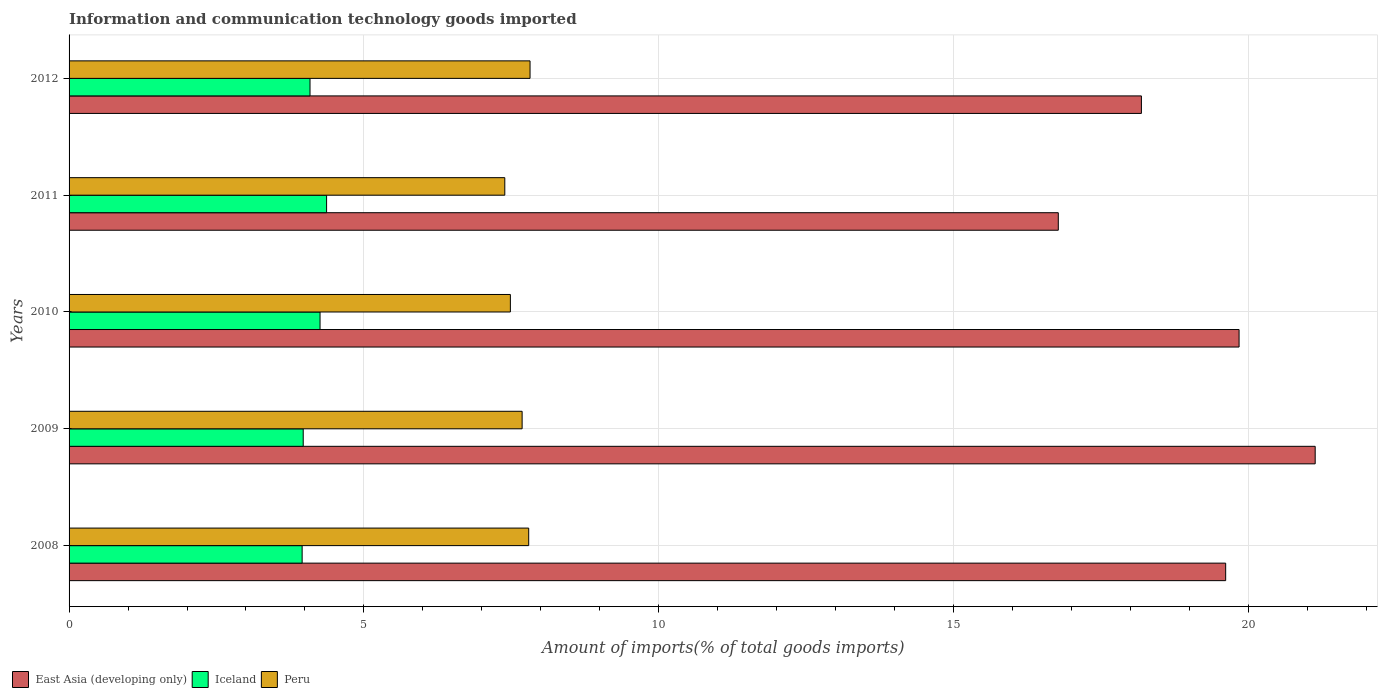How many different coloured bars are there?
Offer a very short reply. 3. How many bars are there on the 4th tick from the top?
Make the answer very short. 3. How many bars are there on the 4th tick from the bottom?
Keep it short and to the point. 3. What is the label of the 1st group of bars from the top?
Your answer should be compact. 2012. In how many cases, is the number of bars for a given year not equal to the number of legend labels?
Your response must be concise. 0. What is the amount of goods imported in Iceland in 2008?
Provide a short and direct response. 3.95. Across all years, what is the maximum amount of goods imported in Peru?
Your answer should be very brief. 7.82. Across all years, what is the minimum amount of goods imported in Peru?
Your answer should be very brief. 7.39. In which year was the amount of goods imported in Iceland maximum?
Provide a succinct answer. 2011. What is the total amount of goods imported in Peru in the graph?
Provide a succinct answer. 38.17. What is the difference between the amount of goods imported in Peru in 2008 and that in 2011?
Make the answer very short. 0.41. What is the difference between the amount of goods imported in Peru in 2011 and the amount of goods imported in Iceland in 2008?
Make the answer very short. 3.44. What is the average amount of goods imported in East Asia (developing only) per year?
Make the answer very short. 19.11. In the year 2008, what is the difference between the amount of goods imported in East Asia (developing only) and amount of goods imported in Peru?
Your response must be concise. 11.82. What is the ratio of the amount of goods imported in East Asia (developing only) in 2009 to that in 2010?
Provide a short and direct response. 1.07. Is the amount of goods imported in Peru in 2008 less than that in 2009?
Provide a succinct answer. No. Is the difference between the amount of goods imported in East Asia (developing only) in 2008 and 2009 greater than the difference between the amount of goods imported in Peru in 2008 and 2009?
Give a very brief answer. No. What is the difference between the highest and the second highest amount of goods imported in Peru?
Your answer should be compact. 0.02. What is the difference between the highest and the lowest amount of goods imported in Iceland?
Your answer should be very brief. 0.41. Is the sum of the amount of goods imported in Iceland in 2009 and 2011 greater than the maximum amount of goods imported in Peru across all years?
Make the answer very short. Yes. What does the 3rd bar from the top in 2009 represents?
Provide a short and direct response. East Asia (developing only). What does the 1st bar from the bottom in 2008 represents?
Offer a very short reply. East Asia (developing only). How many bars are there?
Offer a very short reply. 15. Are all the bars in the graph horizontal?
Give a very brief answer. Yes. What is the difference between two consecutive major ticks on the X-axis?
Make the answer very short. 5. Are the values on the major ticks of X-axis written in scientific E-notation?
Your response must be concise. No. Does the graph contain grids?
Your answer should be compact. Yes. Where does the legend appear in the graph?
Make the answer very short. Bottom left. How many legend labels are there?
Make the answer very short. 3. What is the title of the graph?
Make the answer very short. Information and communication technology goods imported. What is the label or title of the X-axis?
Your response must be concise. Amount of imports(% of total goods imports). What is the Amount of imports(% of total goods imports) in East Asia (developing only) in 2008?
Offer a very short reply. 19.62. What is the Amount of imports(% of total goods imports) of Iceland in 2008?
Offer a very short reply. 3.95. What is the Amount of imports(% of total goods imports) in Peru in 2008?
Keep it short and to the point. 7.8. What is the Amount of imports(% of total goods imports) in East Asia (developing only) in 2009?
Provide a succinct answer. 21.13. What is the Amount of imports(% of total goods imports) in Iceland in 2009?
Make the answer very short. 3.97. What is the Amount of imports(% of total goods imports) of Peru in 2009?
Provide a short and direct response. 7.68. What is the Amount of imports(% of total goods imports) in East Asia (developing only) in 2010?
Give a very brief answer. 19.84. What is the Amount of imports(% of total goods imports) of Iceland in 2010?
Ensure brevity in your answer.  4.26. What is the Amount of imports(% of total goods imports) in Peru in 2010?
Offer a terse response. 7.48. What is the Amount of imports(% of total goods imports) of East Asia (developing only) in 2011?
Make the answer very short. 16.78. What is the Amount of imports(% of total goods imports) in Iceland in 2011?
Offer a very short reply. 4.37. What is the Amount of imports(% of total goods imports) in Peru in 2011?
Provide a short and direct response. 7.39. What is the Amount of imports(% of total goods imports) in East Asia (developing only) in 2012?
Give a very brief answer. 18.19. What is the Amount of imports(% of total goods imports) in Iceland in 2012?
Your response must be concise. 4.09. What is the Amount of imports(% of total goods imports) of Peru in 2012?
Your answer should be compact. 7.82. Across all years, what is the maximum Amount of imports(% of total goods imports) in East Asia (developing only)?
Offer a very short reply. 21.13. Across all years, what is the maximum Amount of imports(% of total goods imports) in Iceland?
Your answer should be compact. 4.37. Across all years, what is the maximum Amount of imports(% of total goods imports) of Peru?
Your answer should be compact. 7.82. Across all years, what is the minimum Amount of imports(% of total goods imports) of East Asia (developing only)?
Your answer should be compact. 16.78. Across all years, what is the minimum Amount of imports(% of total goods imports) in Iceland?
Your response must be concise. 3.95. Across all years, what is the minimum Amount of imports(% of total goods imports) in Peru?
Offer a terse response. 7.39. What is the total Amount of imports(% of total goods imports) in East Asia (developing only) in the graph?
Offer a very short reply. 95.56. What is the total Amount of imports(% of total goods imports) in Iceland in the graph?
Provide a succinct answer. 20.64. What is the total Amount of imports(% of total goods imports) of Peru in the graph?
Make the answer very short. 38.17. What is the difference between the Amount of imports(% of total goods imports) of East Asia (developing only) in 2008 and that in 2009?
Keep it short and to the point. -1.52. What is the difference between the Amount of imports(% of total goods imports) of Iceland in 2008 and that in 2009?
Your answer should be very brief. -0.02. What is the difference between the Amount of imports(% of total goods imports) of Peru in 2008 and that in 2009?
Give a very brief answer. 0.11. What is the difference between the Amount of imports(% of total goods imports) in East Asia (developing only) in 2008 and that in 2010?
Your answer should be compact. -0.23. What is the difference between the Amount of imports(% of total goods imports) of Iceland in 2008 and that in 2010?
Offer a terse response. -0.3. What is the difference between the Amount of imports(% of total goods imports) of Peru in 2008 and that in 2010?
Offer a very short reply. 0.31. What is the difference between the Amount of imports(% of total goods imports) of East Asia (developing only) in 2008 and that in 2011?
Make the answer very short. 2.84. What is the difference between the Amount of imports(% of total goods imports) in Iceland in 2008 and that in 2011?
Your response must be concise. -0.41. What is the difference between the Amount of imports(% of total goods imports) of Peru in 2008 and that in 2011?
Keep it short and to the point. 0.41. What is the difference between the Amount of imports(% of total goods imports) of East Asia (developing only) in 2008 and that in 2012?
Your answer should be very brief. 1.43. What is the difference between the Amount of imports(% of total goods imports) of Iceland in 2008 and that in 2012?
Your answer should be very brief. -0.13. What is the difference between the Amount of imports(% of total goods imports) of Peru in 2008 and that in 2012?
Ensure brevity in your answer.  -0.02. What is the difference between the Amount of imports(% of total goods imports) in East Asia (developing only) in 2009 and that in 2010?
Keep it short and to the point. 1.29. What is the difference between the Amount of imports(% of total goods imports) in Iceland in 2009 and that in 2010?
Offer a very short reply. -0.29. What is the difference between the Amount of imports(% of total goods imports) in Peru in 2009 and that in 2010?
Offer a very short reply. 0.2. What is the difference between the Amount of imports(% of total goods imports) in East Asia (developing only) in 2009 and that in 2011?
Your answer should be compact. 4.36. What is the difference between the Amount of imports(% of total goods imports) of Iceland in 2009 and that in 2011?
Offer a terse response. -0.4. What is the difference between the Amount of imports(% of total goods imports) of Peru in 2009 and that in 2011?
Keep it short and to the point. 0.29. What is the difference between the Amount of imports(% of total goods imports) in East Asia (developing only) in 2009 and that in 2012?
Your response must be concise. 2.95. What is the difference between the Amount of imports(% of total goods imports) in Iceland in 2009 and that in 2012?
Offer a terse response. -0.12. What is the difference between the Amount of imports(% of total goods imports) in Peru in 2009 and that in 2012?
Provide a short and direct response. -0.13. What is the difference between the Amount of imports(% of total goods imports) of East Asia (developing only) in 2010 and that in 2011?
Provide a succinct answer. 3.07. What is the difference between the Amount of imports(% of total goods imports) of Iceland in 2010 and that in 2011?
Provide a succinct answer. -0.11. What is the difference between the Amount of imports(% of total goods imports) of Peru in 2010 and that in 2011?
Your response must be concise. 0.09. What is the difference between the Amount of imports(% of total goods imports) in East Asia (developing only) in 2010 and that in 2012?
Keep it short and to the point. 1.66. What is the difference between the Amount of imports(% of total goods imports) of Iceland in 2010 and that in 2012?
Your answer should be very brief. 0.17. What is the difference between the Amount of imports(% of total goods imports) of Peru in 2010 and that in 2012?
Ensure brevity in your answer.  -0.33. What is the difference between the Amount of imports(% of total goods imports) of East Asia (developing only) in 2011 and that in 2012?
Ensure brevity in your answer.  -1.41. What is the difference between the Amount of imports(% of total goods imports) in Iceland in 2011 and that in 2012?
Provide a succinct answer. 0.28. What is the difference between the Amount of imports(% of total goods imports) in Peru in 2011 and that in 2012?
Offer a terse response. -0.43. What is the difference between the Amount of imports(% of total goods imports) of East Asia (developing only) in 2008 and the Amount of imports(% of total goods imports) of Iceland in 2009?
Make the answer very short. 15.64. What is the difference between the Amount of imports(% of total goods imports) of East Asia (developing only) in 2008 and the Amount of imports(% of total goods imports) of Peru in 2009?
Provide a short and direct response. 11.93. What is the difference between the Amount of imports(% of total goods imports) in Iceland in 2008 and the Amount of imports(% of total goods imports) in Peru in 2009?
Provide a succinct answer. -3.73. What is the difference between the Amount of imports(% of total goods imports) in East Asia (developing only) in 2008 and the Amount of imports(% of total goods imports) in Iceland in 2010?
Give a very brief answer. 15.36. What is the difference between the Amount of imports(% of total goods imports) of East Asia (developing only) in 2008 and the Amount of imports(% of total goods imports) of Peru in 2010?
Offer a terse response. 12.13. What is the difference between the Amount of imports(% of total goods imports) of Iceland in 2008 and the Amount of imports(% of total goods imports) of Peru in 2010?
Your response must be concise. -3.53. What is the difference between the Amount of imports(% of total goods imports) of East Asia (developing only) in 2008 and the Amount of imports(% of total goods imports) of Iceland in 2011?
Make the answer very short. 15.25. What is the difference between the Amount of imports(% of total goods imports) of East Asia (developing only) in 2008 and the Amount of imports(% of total goods imports) of Peru in 2011?
Offer a terse response. 12.23. What is the difference between the Amount of imports(% of total goods imports) in Iceland in 2008 and the Amount of imports(% of total goods imports) in Peru in 2011?
Provide a succinct answer. -3.44. What is the difference between the Amount of imports(% of total goods imports) of East Asia (developing only) in 2008 and the Amount of imports(% of total goods imports) of Iceland in 2012?
Your answer should be compact. 15.53. What is the difference between the Amount of imports(% of total goods imports) of East Asia (developing only) in 2008 and the Amount of imports(% of total goods imports) of Peru in 2012?
Offer a terse response. 11.8. What is the difference between the Amount of imports(% of total goods imports) of Iceland in 2008 and the Amount of imports(% of total goods imports) of Peru in 2012?
Give a very brief answer. -3.87. What is the difference between the Amount of imports(% of total goods imports) of East Asia (developing only) in 2009 and the Amount of imports(% of total goods imports) of Iceland in 2010?
Give a very brief answer. 16.88. What is the difference between the Amount of imports(% of total goods imports) of East Asia (developing only) in 2009 and the Amount of imports(% of total goods imports) of Peru in 2010?
Offer a terse response. 13.65. What is the difference between the Amount of imports(% of total goods imports) in Iceland in 2009 and the Amount of imports(% of total goods imports) in Peru in 2010?
Keep it short and to the point. -3.51. What is the difference between the Amount of imports(% of total goods imports) of East Asia (developing only) in 2009 and the Amount of imports(% of total goods imports) of Iceland in 2011?
Provide a succinct answer. 16.77. What is the difference between the Amount of imports(% of total goods imports) of East Asia (developing only) in 2009 and the Amount of imports(% of total goods imports) of Peru in 2011?
Ensure brevity in your answer.  13.74. What is the difference between the Amount of imports(% of total goods imports) in Iceland in 2009 and the Amount of imports(% of total goods imports) in Peru in 2011?
Make the answer very short. -3.42. What is the difference between the Amount of imports(% of total goods imports) in East Asia (developing only) in 2009 and the Amount of imports(% of total goods imports) in Iceland in 2012?
Keep it short and to the point. 17.05. What is the difference between the Amount of imports(% of total goods imports) in East Asia (developing only) in 2009 and the Amount of imports(% of total goods imports) in Peru in 2012?
Your response must be concise. 13.32. What is the difference between the Amount of imports(% of total goods imports) in Iceland in 2009 and the Amount of imports(% of total goods imports) in Peru in 2012?
Make the answer very short. -3.85. What is the difference between the Amount of imports(% of total goods imports) in East Asia (developing only) in 2010 and the Amount of imports(% of total goods imports) in Iceland in 2011?
Offer a terse response. 15.48. What is the difference between the Amount of imports(% of total goods imports) of East Asia (developing only) in 2010 and the Amount of imports(% of total goods imports) of Peru in 2011?
Give a very brief answer. 12.45. What is the difference between the Amount of imports(% of total goods imports) in Iceland in 2010 and the Amount of imports(% of total goods imports) in Peru in 2011?
Ensure brevity in your answer.  -3.13. What is the difference between the Amount of imports(% of total goods imports) in East Asia (developing only) in 2010 and the Amount of imports(% of total goods imports) in Iceland in 2012?
Offer a very short reply. 15.76. What is the difference between the Amount of imports(% of total goods imports) of East Asia (developing only) in 2010 and the Amount of imports(% of total goods imports) of Peru in 2012?
Keep it short and to the point. 12.03. What is the difference between the Amount of imports(% of total goods imports) of Iceland in 2010 and the Amount of imports(% of total goods imports) of Peru in 2012?
Provide a short and direct response. -3.56. What is the difference between the Amount of imports(% of total goods imports) in East Asia (developing only) in 2011 and the Amount of imports(% of total goods imports) in Iceland in 2012?
Make the answer very short. 12.69. What is the difference between the Amount of imports(% of total goods imports) of East Asia (developing only) in 2011 and the Amount of imports(% of total goods imports) of Peru in 2012?
Give a very brief answer. 8.96. What is the difference between the Amount of imports(% of total goods imports) of Iceland in 2011 and the Amount of imports(% of total goods imports) of Peru in 2012?
Provide a succinct answer. -3.45. What is the average Amount of imports(% of total goods imports) of East Asia (developing only) per year?
Offer a terse response. 19.11. What is the average Amount of imports(% of total goods imports) in Iceland per year?
Provide a short and direct response. 4.13. What is the average Amount of imports(% of total goods imports) in Peru per year?
Offer a very short reply. 7.63. In the year 2008, what is the difference between the Amount of imports(% of total goods imports) of East Asia (developing only) and Amount of imports(% of total goods imports) of Iceland?
Give a very brief answer. 15.66. In the year 2008, what is the difference between the Amount of imports(% of total goods imports) in East Asia (developing only) and Amount of imports(% of total goods imports) in Peru?
Provide a succinct answer. 11.82. In the year 2008, what is the difference between the Amount of imports(% of total goods imports) of Iceland and Amount of imports(% of total goods imports) of Peru?
Your response must be concise. -3.84. In the year 2009, what is the difference between the Amount of imports(% of total goods imports) of East Asia (developing only) and Amount of imports(% of total goods imports) of Iceland?
Provide a short and direct response. 17.16. In the year 2009, what is the difference between the Amount of imports(% of total goods imports) of East Asia (developing only) and Amount of imports(% of total goods imports) of Peru?
Ensure brevity in your answer.  13.45. In the year 2009, what is the difference between the Amount of imports(% of total goods imports) of Iceland and Amount of imports(% of total goods imports) of Peru?
Your response must be concise. -3.71. In the year 2010, what is the difference between the Amount of imports(% of total goods imports) in East Asia (developing only) and Amount of imports(% of total goods imports) in Iceland?
Keep it short and to the point. 15.59. In the year 2010, what is the difference between the Amount of imports(% of total goods imports) in East Asia (developing only) and Amount of imports(% of total goods imports) in Peru?
Offer a very short reply. 12.36. In the year 2010, what is the difference between the Amount of imports(% of total goods imports) in Iceland and Amount of imports(% of total goods imports) in Peru?
Keep it short and to the point. -3.23. In the year 2011, what is the difference between the Amount of imports(% of total goods imports) of East Asia (developing only) and Amount of imports(% of total goods imports) of Iceland?
Provide a short and direct response. 12.41. In the year 2011, what is the difference between the Amount of imports(% of total goods imports) of East Asia (developing only) and Amount of imports(% of total goods imports) of Peru?
Your response must be concise. 9.39. In the year 2011, what is the difference between the Amount of imports(% of total goods imports) of Iceland and Amount of imports(% of total goods imports) of Peru?
Offer a terse response. -3.02. In the year 2012, what is the difference between the Amount of imports(% of total goods imports) in East Asia (developing only) and Amount of imports(% of total goods imports) in Iceland?
Make the answer very short. 14.1. In the year 2012, what is the difference between the Amount of imports(% of total goods imports) in East Asia (developing only) and Amount of imports(% of total goods imports) in Peru?
Keep it short and to the point. 10.37. In the year 2012, what is the difference between the Amount of imports(% of total goods imports) in Iceland and Amount of imports(% of total goods imports) in Peru?
Ensure brevity in your answer.  -3.73. What is the ratio of the Amount of imports(% of total goods imports) in East Asia (developing only) in 2008 to that in 2009?
Give a very brief answer. 0.93. What is the ratio of the Amount of imports(% of total goods imports) in Peru in 2008 to that in 2009?
Keep it short and to the point. 1.01. What is the ratio of the Amount of imports(% of total goods imports) of East Asia (developing only) in 2008 to that in 2010?
Provide a short and direct response. 0.99. What is the ratio of the Amount of imports(% of total goods imports) in Iceland in 2008 to that in 2010?
Your answer should be very brief. 0.93. What is the ratio of the Amount of imports(% of total goods imports) of Peru in 2008 to that in 2010?
Give a very brief answer. 1.04. What is the ratio of the Amount of imports(% of total goods imports) in East Asia (developing only) in 2008 to that in 2011?
Offer a terse response. 1.17. What is the ratio of the Amount of imports(% of total goods imports) of Iceland in 2008 to that in 2011?
Give a very brief answer. 0.91. What is the ratio of the Amount of imports(% of total goods imports) in Peru in 2008 to that in 2011?
Your answer should be very brief. 1.05. What is the ratio of the Amount of imports(% of total goods imports) in East Asia (developing only) in 2008 to that in 2012?
Your answer should be compact. 1.08. What is the ratio of the Amount of imports(% of total goods imports) of Iceland in 2008 to that in 2012?
Your answer should be very brief. 0.97. What is the ratio of the Amount of imports(% of total goods imports) in Peru in 2008 to that in 2012?
Provide a succinct answer. 1. What is the ratio of the Amount of imports(% of total goods imports) of East Asia (developing only) in 2009 to that in 2010?
Provide a succinct answer. 1.06. What is the ratio of the Amount of imports(% of total goods imports) in Iceland in 2009 to that in 2010?
Ensure brevity in your answer.  0.93. What is the ratio of the Amount of imports(% of total goods imports) in Peru in 2009 to that in 2010?
Your response must be concise. 1.03. What is the ratio of the Amount of imports(% of total goods imports) in East Asia (developing only) in 2009 to that in 2011?
Ensure brevity in your answer.  1.26. What is the ratio of the Amount of imports(% of total goods imports) of Iceland in 2009 to that in 2011?
Keep it short and to the point. 0.91. What is the ratio of the Amount of imports(% of total goods imports) of Peru in 2009 to that in 2011?
Offer a terse response. 1.04. What is the ratio of the Amount of imports(% of total goods imports) of East Asia (developing only) in 2009 to that in 2012?
Ensure brevity in your answer.  1.16. What is the ratio of the Amount of imports(% of total goods imports) in Iceland in 2009 to that in 2012?
Your response must be concise. 0.97. What is the ratio of the Amount of imports(% of total goods imports) in Peru in 2009 to that in 2012?
Provide a succinct answer. 0.98. What is the ratio of the Amount of imports(% of total goods imports) of East Asia (developing only) in 2010 to that in 2011?
Your answer should be compact. 1.18. What is the ratio of the Amount of imports(% of total goods imports) of Iceland in 2010 to that in 2011?
Your answer should be compact. 0.97. What is the ratio of the Amount of imports(% of total goods imports) in Peru in 2010 to that in 2011?
Offer a terse response. 1.01. What is the ratio of the Amount of imports(% of total goods imports) in East Asia (developing only) in 2010 to that in 2012?
Ensure brevity in your answer.  1.09. What is the ratio of the Amount of imports(% of total goods imports) of Iceland in 2010 to that in 2012?
Your answer should be compact. 1.04. What is the ratio of the Amount of imports(% of total goods imports) in Peru in 2010 to that in 2012?
Your answer should be compact. 0.96. What is the ratio of the Amount of imports(% of total goods imports) in East Asia (developing only) in 2011 to that in 2012?
Offer a very short reply. 0.92. What is the ratio of the Amount of imports(% of total goods imports) in Iceland in 2011 to that in 2012?
Keep it short and to the point. 1.07. What is the ratio of the Amount of imports(% of total goods imports) of Peru in 2011 to that in 2012?
Your response must be concise. 0.95. What is the difference between the highest and the second highest Amount of imports(% of total goods imports) of East Asia (developing only)?
Provide a succinct answer. 1.29. What is the difference between the highest and the second highest Amount of imports(% of total goods imports) of Iceland?
Your answer should be compact. 0.11. What is the difference between the highest and the second highest Amount of imports(% of total goods imports) in Peru?
Make the answer very short. 0.02. What is the difference between the highest and the lowest Amount of imports(% of total goods imports) in East Asia (developing only)?
Provide a short and direct response. 4.36. What is the difference between the highest and the lowest Amount of imports(% of total goods imports) in Iceland?
Offer a very short reply. 0.41. What is the difference between the highest and the lowest Amount of imports(% of total goods imports) in Peru?
Keep it short and to the point. 0.43. 